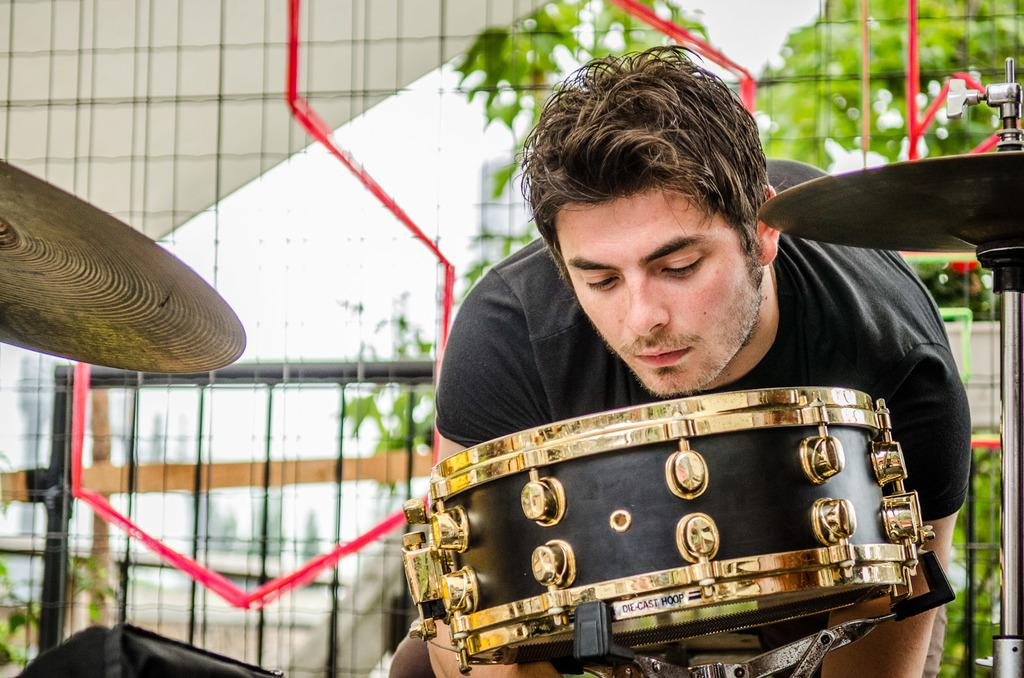What is the person in the image doing? The person in the image is bending. What can be seen in the background of the image? There are musical instruments and trees in the background of the image. What type of material is visible in the image? There is a mesh visible in the image. What type of pies can be seen in the image? There are no pies present in the image. What kind of bear is interacting with the person in the image? There is no bear present in the image. 